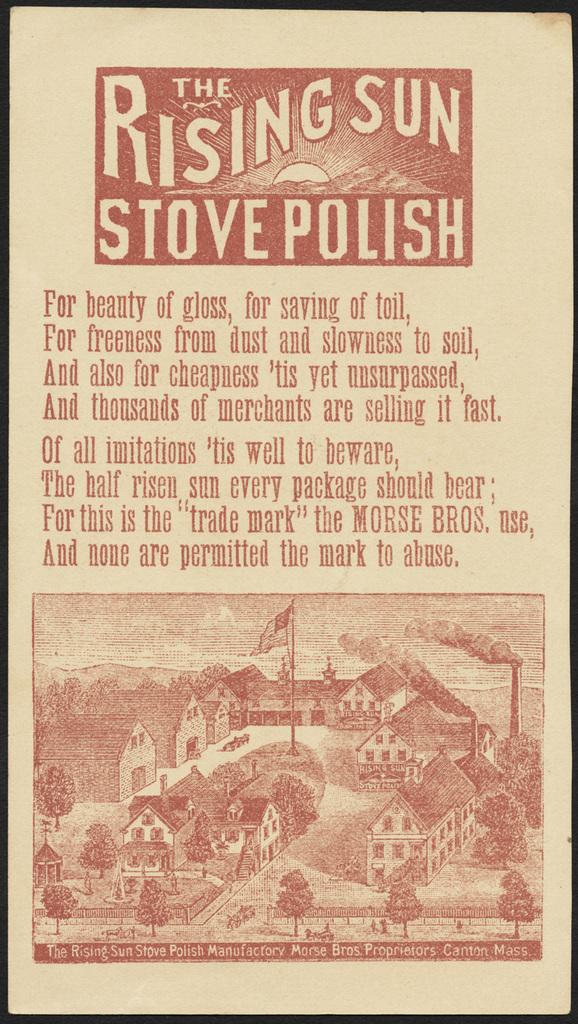<image>
Offer a succinct explanation of the picture presented. An old pamphlet that says The Rising Sun Stove Polish 